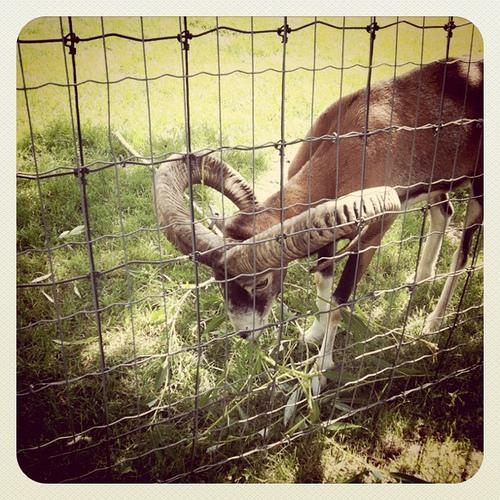Using concise language, explain the focus of the image and what the main subject is doing. Ram stands on grass, with head bent down, eating plant by fence. How would you describe the key details of the scene in a single sentence? A four-legged creature with a curved horn is grazing near a fenced area while the sun shines. Please describe the primary creature and its setting in a casual, conversational style. Hey, there's a ram hanging out on the grass, and it looks like it's snacking on a plant near a fence. Give a brief, child-friendly description of the main subject and its action within the image. In the picture, there's a fluffy ram with big, curly horns standing on the soft, green grass and eating yummy plants near a fence. Write a short narrative capturing the main subject and the environment. On a sunny day, a ram with long curved horns roamed the grassy field, its neck bent down to satisfy its hunger with a plant by the fence. Create a short poetic description of the main subject and its surroundings. Upon verdant grass stands a gallant ram, its curved horns in grace, a plant devoured behind a wired fence's embrace. Write a brief description of the primary object and its action in the scene. A ram is standing on the grass, its head bent down, possibly eating a plant by the fence. What animal is depicted in the image, and what is the interaction between the animal and the environment? A goat is shown in the picture, standing on the grass and eating a plant near the fence. Write an informal, humorous observation of the primary character's action and setting. This ram looks like it's having the best day ever, just chilling on the grass and munching on a plant like nobody's business! Explain what's happening in the image like you're telling a friend about it. So, there's this picture of a ram standing on the grass and nibbling on a plant by a fence – it's such a peaceful scene! 